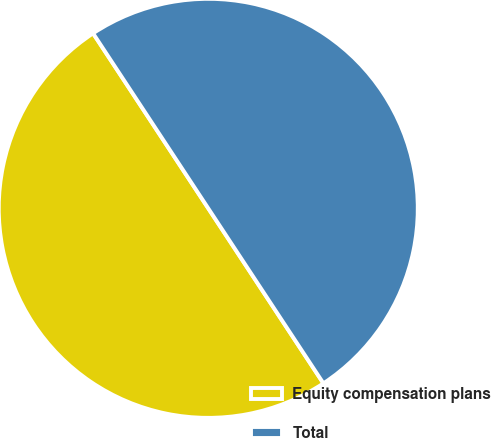<chart> <loc_0><loc_0><loc_500><loc_500><pie_chart><fcel>Equity compensation plans<fcel>Total<nl><fcel>50.0%<fcel>50.0%<nl></chart> 